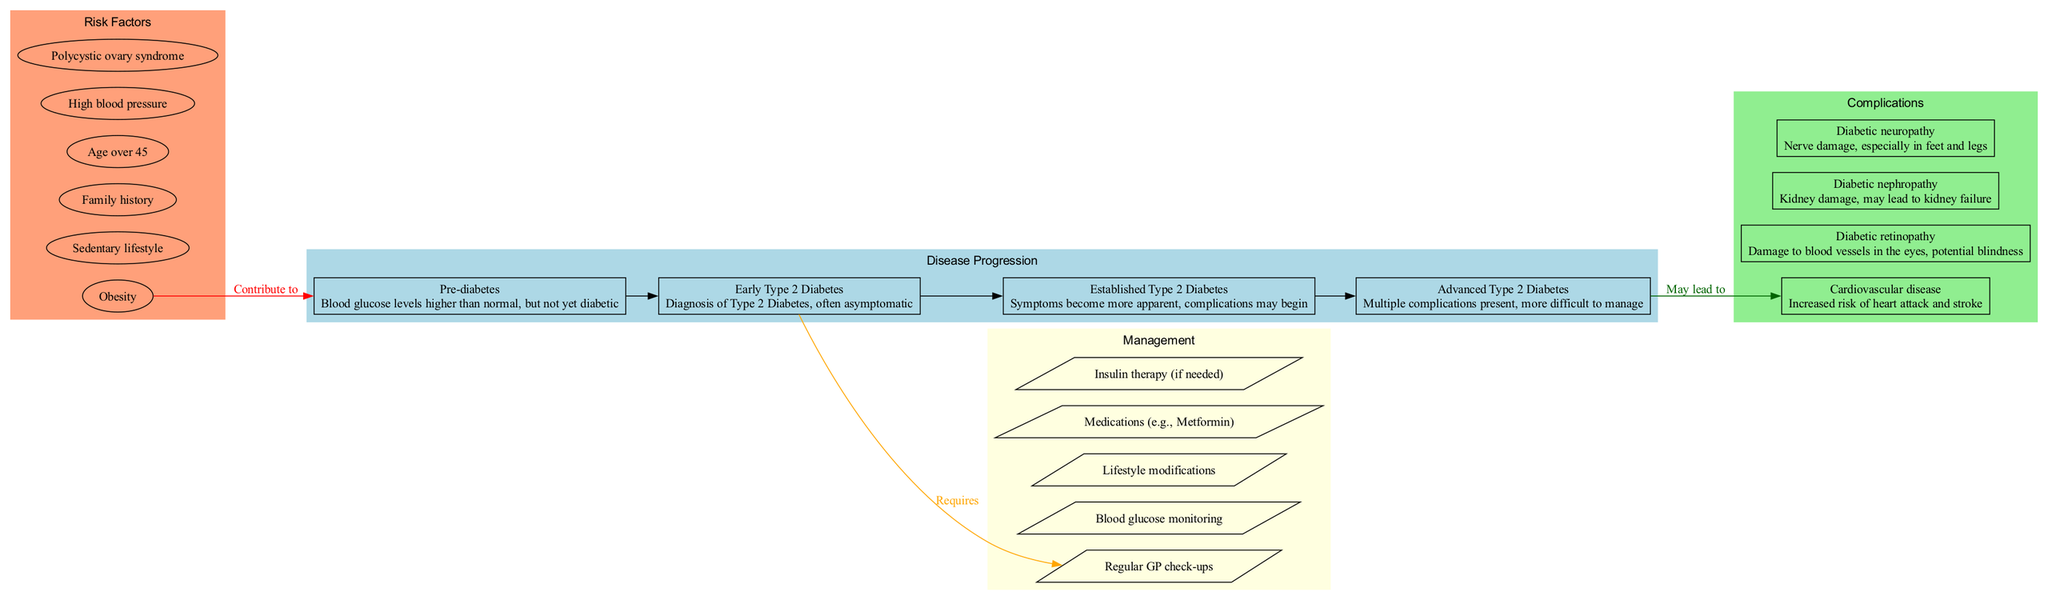What is the first stage of Type 2 Diabetes? According to the diagram, the first stage listed is "Pre-diabetes," defined as having blood glucose levels higher than normal but not yet diabetic.
Answer: Pre-diabetes How many risk factors are listed in the diagram? The diagram includes a total of six risk factors for Type 2 Diabetes mentioned in the section labeled 'Risk Factors.'
Answer: 6 What complication is associated with the risk of heart attack and stroke? The complication related to the increased risk of heart attack and stroke is "Cardiovascular disease" as indicated in the Complications section of the diagram.
Answer: Cardiovascular disease What stage requires management according to the diagram? The diagram indicates that the "Early Type 2 Diabetes" stage requires management, as shown by the edge connecting it to the management section.
Answer: Early Type 2 Diabetes Which stage may lead to complications? The diagram shows that "Advanced Type 2 Diabetes" is linked to multiple complications, indicating it may lead to complications according to the flow of the diagram.
Answer: Advanced Type 2 Diabetes What lifestyle change is mentioned as a part of management? The diagram lists "Lifestyle modifications" as one of the management strategies for Type 2 Diabetes, highlighting its importance in overall management.
Answer: Lifestyle modifications Which risk factor contributes to the onset of Type 2 Diabetes? The diagram states that "Obesity" is a risk factor that contributes to the onset of Type 2 Diabetes, illustrated by the directed edge connecting it to the disease progression.
Answer: Obesity How many stages of Type 2 Diabetes are depicted in the diagram? The diagram depicts four distinct stages of Type 2 Diabetes, which are outlined under the section for disease progression.
Answer: 4 What color represents the 'Management' section in the diagram? The 'Management' section of the diagram is filled with the color light yellow, which helps differentiate it visually from other sections.
Answer: Light yellow 